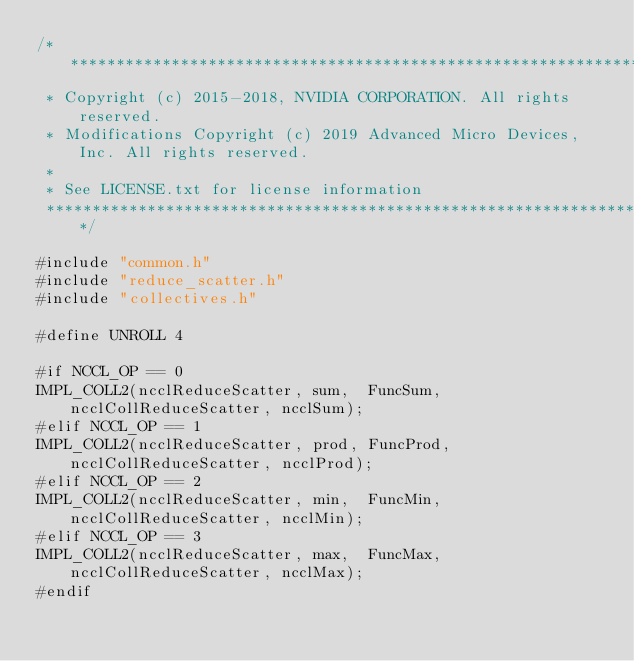<code> <loc_0><loc_0><loc_500><loc_500><_Cuda_>/*************************************************************************
 * Copyright (c) 2015-2018, NVIDIA CORPORATION. All rights reserved.
 * Modifications Copyright (c) 2019 Advanced Micro Devices, Inc. All rights reserved.
 *
 * See LICENSE.txt for license information
 ************************************************************************/

#include "common.h"
#include "reduce_scatter.h"
#include "collectives.h"

#define UNROLL 4

#if NCCL_OP == 0
IMPL_COLL2(ncclReduceScatter, sum,  FuncSum,  ncclCollReduceScatter, ncclSum);
#elif NCCL_OP == 1
IMPL_COLL2(ncclReduceScatter, prod, FuncProd, ncclCollReduceScatter, ncclProd);
#elif NCCL_OP == 2
IMPL_COLL2(ncclReduceScatter, min,  FuncMin,  ncclCollReduceScatter, ncclMin);
#elif NCCL_OP == 3
IMPL_COLL2(ncclReduceScatter, max,  FuncMax,  ncclCollReduceScatter, ncclMax);
#endif
</code> 